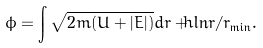Convert formula to latex. <formula><loc_0><loc_0><loc_500><loc_500>\phi = \int \sqrt { 2 m ( U + | E | ) } d r + \hbar { \ln } r / { r _ { \min } } .</formula> 